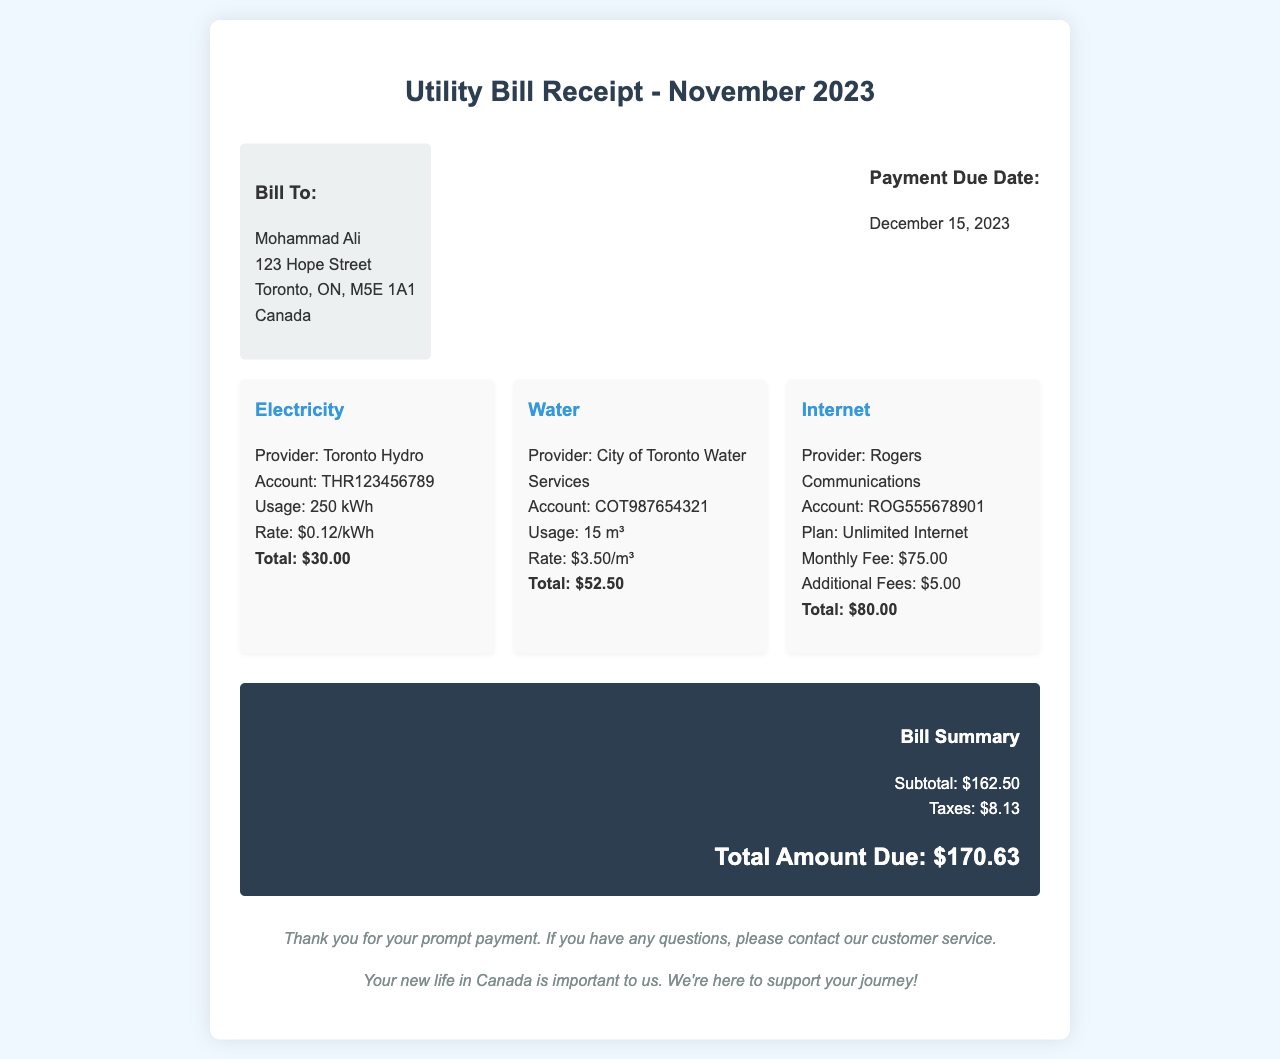What is the total amount due? The total amount due is indicated at the bottom of the receipt, encompassing all charges after taxes, which is $170.63.
Answer: $170.63 Who is the electricity provider? The electricity provider is stated in the electricity section of the bill, which is Toronto Hydro.
Answer: Toronto Hydro What is the payment due date? The payment due date is specified clearly in the document as December 15, 2023.
Answer: December 15, 2023 How much was the water charge? The water charge is detailed in the water section, listing the total as $52.50.
Answer: $52.50 What is the plan for the internet service? The internet section describes the service plan explicitly as Unlimited Internet.
Answer: Unlimited Internet What is the total usage of electricity? The total electricity usage is mentioned in the electricity section of the bill, which is 250 kWh.
Answer: 250 kWh What are the additional fees for the internet? The additional fees for the internet service are clearly stated in the document as $5.00.
Answer: $5.00 What is the subtotal amount before taxes? The subtotal amount before taxes can be found in the bill summary, specifically listed as $162.50.
Answer: $162.50 What is the total charge for the internet service? The total charge for the internet service can be found in the internet section, which shows a total of $80.00.
Answer: $80.00 